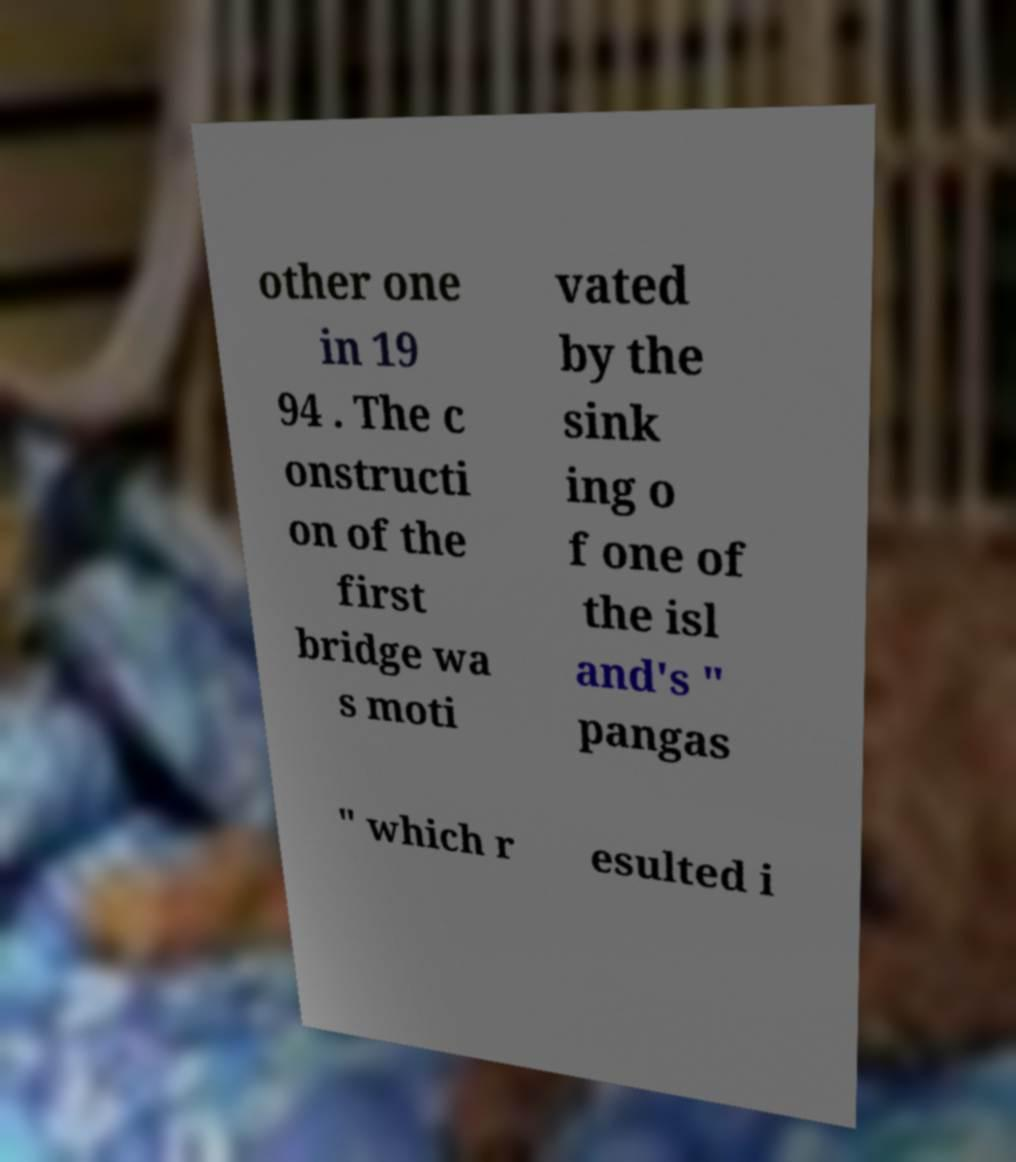What messages or text are displayed in this image? I need them in a readable, typed format. other one in 19 94 . The c onstructi on of the first bridge wa s moti vated by the sink ing o f one of the isl and's " pangas " which r esulted i 